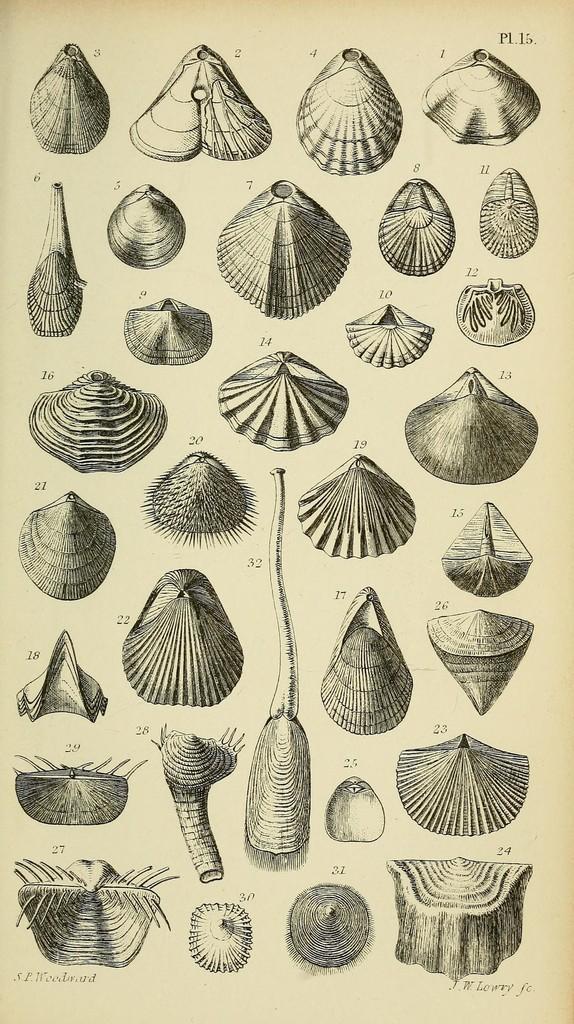Please provide a concise description of this image. In this image we can see the different types of shell pictures on the paper. 